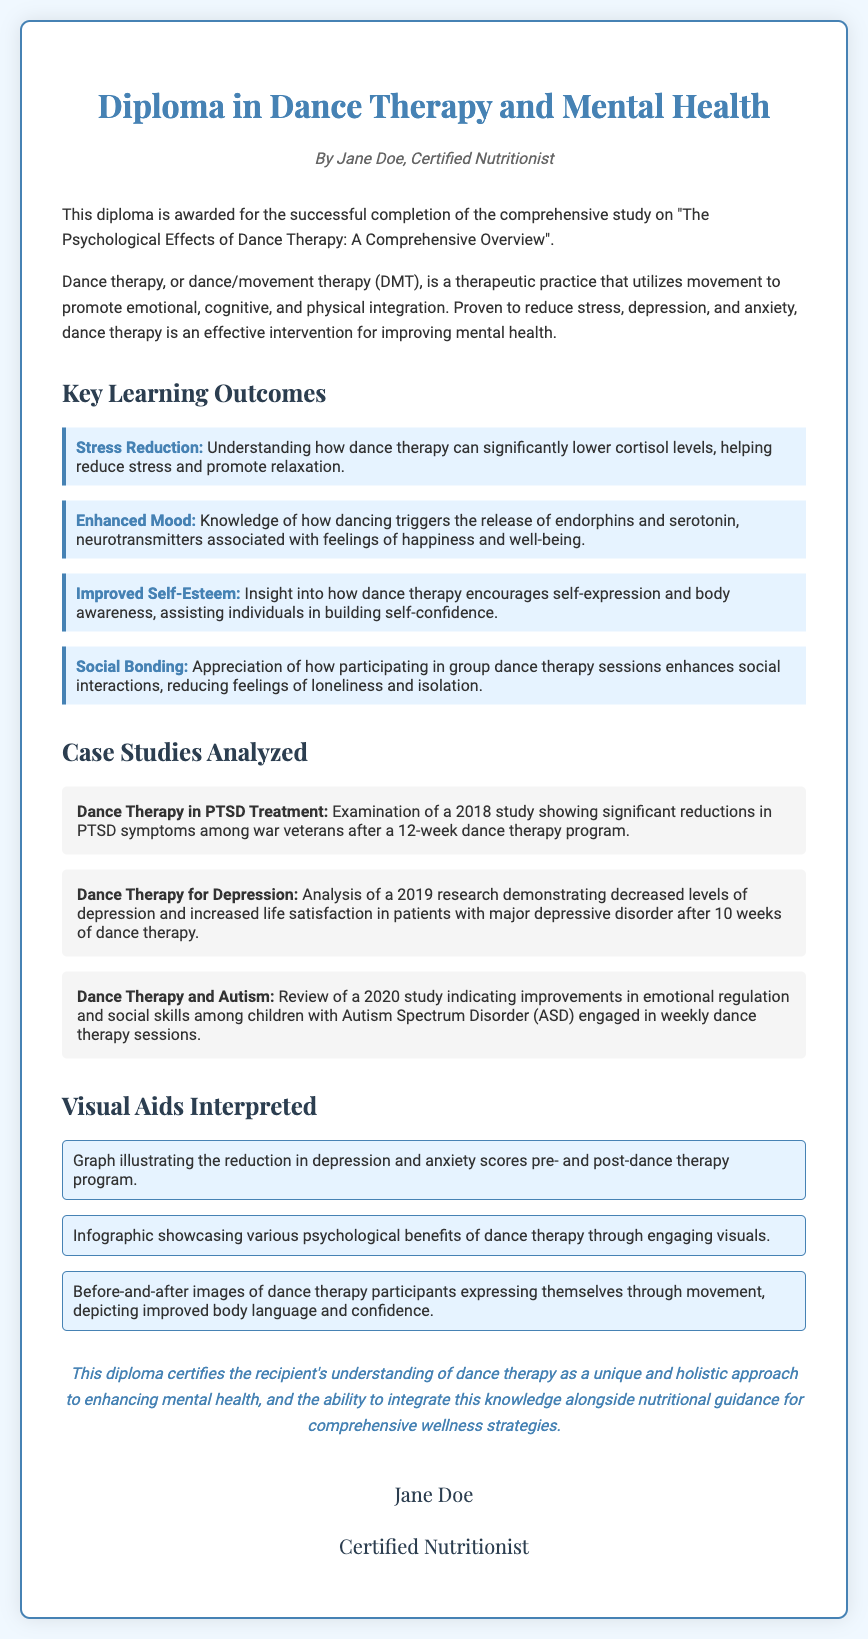What is the title of the diploma? The title of the diploma is clearly stated at the top of the document as "Diploma in Dance Therapy and Mental Health".
Answer: Diploma in Dance Therapy and Mental Health Who is the author of the diploma? The author of the diploma is mentioned below the title as "Jane Doe, Certified Nutritionist".
Answer: Jane Doe, Certified Nutritionist What year was the study on PTSD treatment conducted? The document states that the study on PTSD treatment was conducted in 2018.
Answer: 2018 What is one psychological benefit of dance therapy mentioned? The document lists several benefits; one of them is the reduction of cortisol levels related to stress.
Answer: Stress Reduction How many case studies are analyzed in the document? The document mentions three specific case studies that were analyzed.
Answer: Three What visual aid illustrates improvement in scores related to dance therapy? A graph illustrating the reduction in depression and anxiety scores pre- and post-dance therapy program is mentioned as a visual aid.
Answer: Graph What does the conclusion certify regarding the recipient? The conclusion certifies the recipient's understanding of dance therapy and its integration with nutritional guidance.
Answer: Understanding of dance therapy How many weeks was the dance therapy program for depression? The document specifies that the dance therapy program for depression lasted for 10 weeks.
Answer: 10 weeks What is the primary focus of the diploma? The primary focus of the diploma is on the psychological effects of dance therapy in relation to mental health.
Answer: Psychological effects of dance therapy 